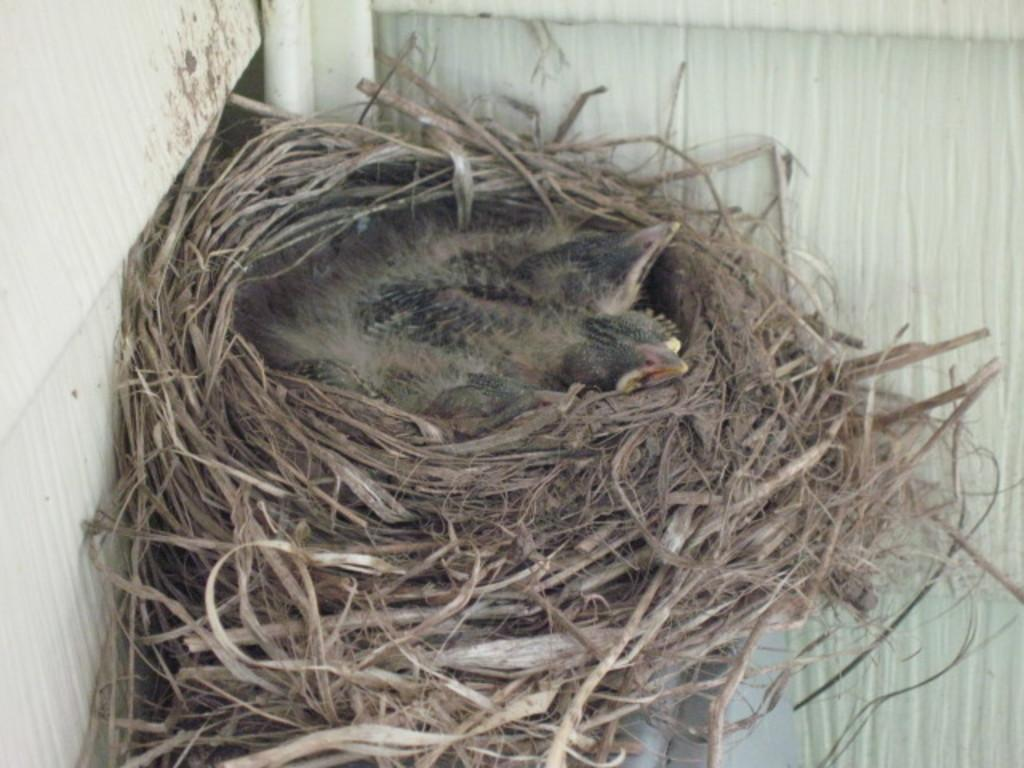What type of animals can be seen in the image? Birds can be seen in the image. Where are the birds located in the image? The birds are in a nest. What type of mist can be seen surrounding the hill in the image? There is no hill or mist present in the image; it features birds in a nest. 